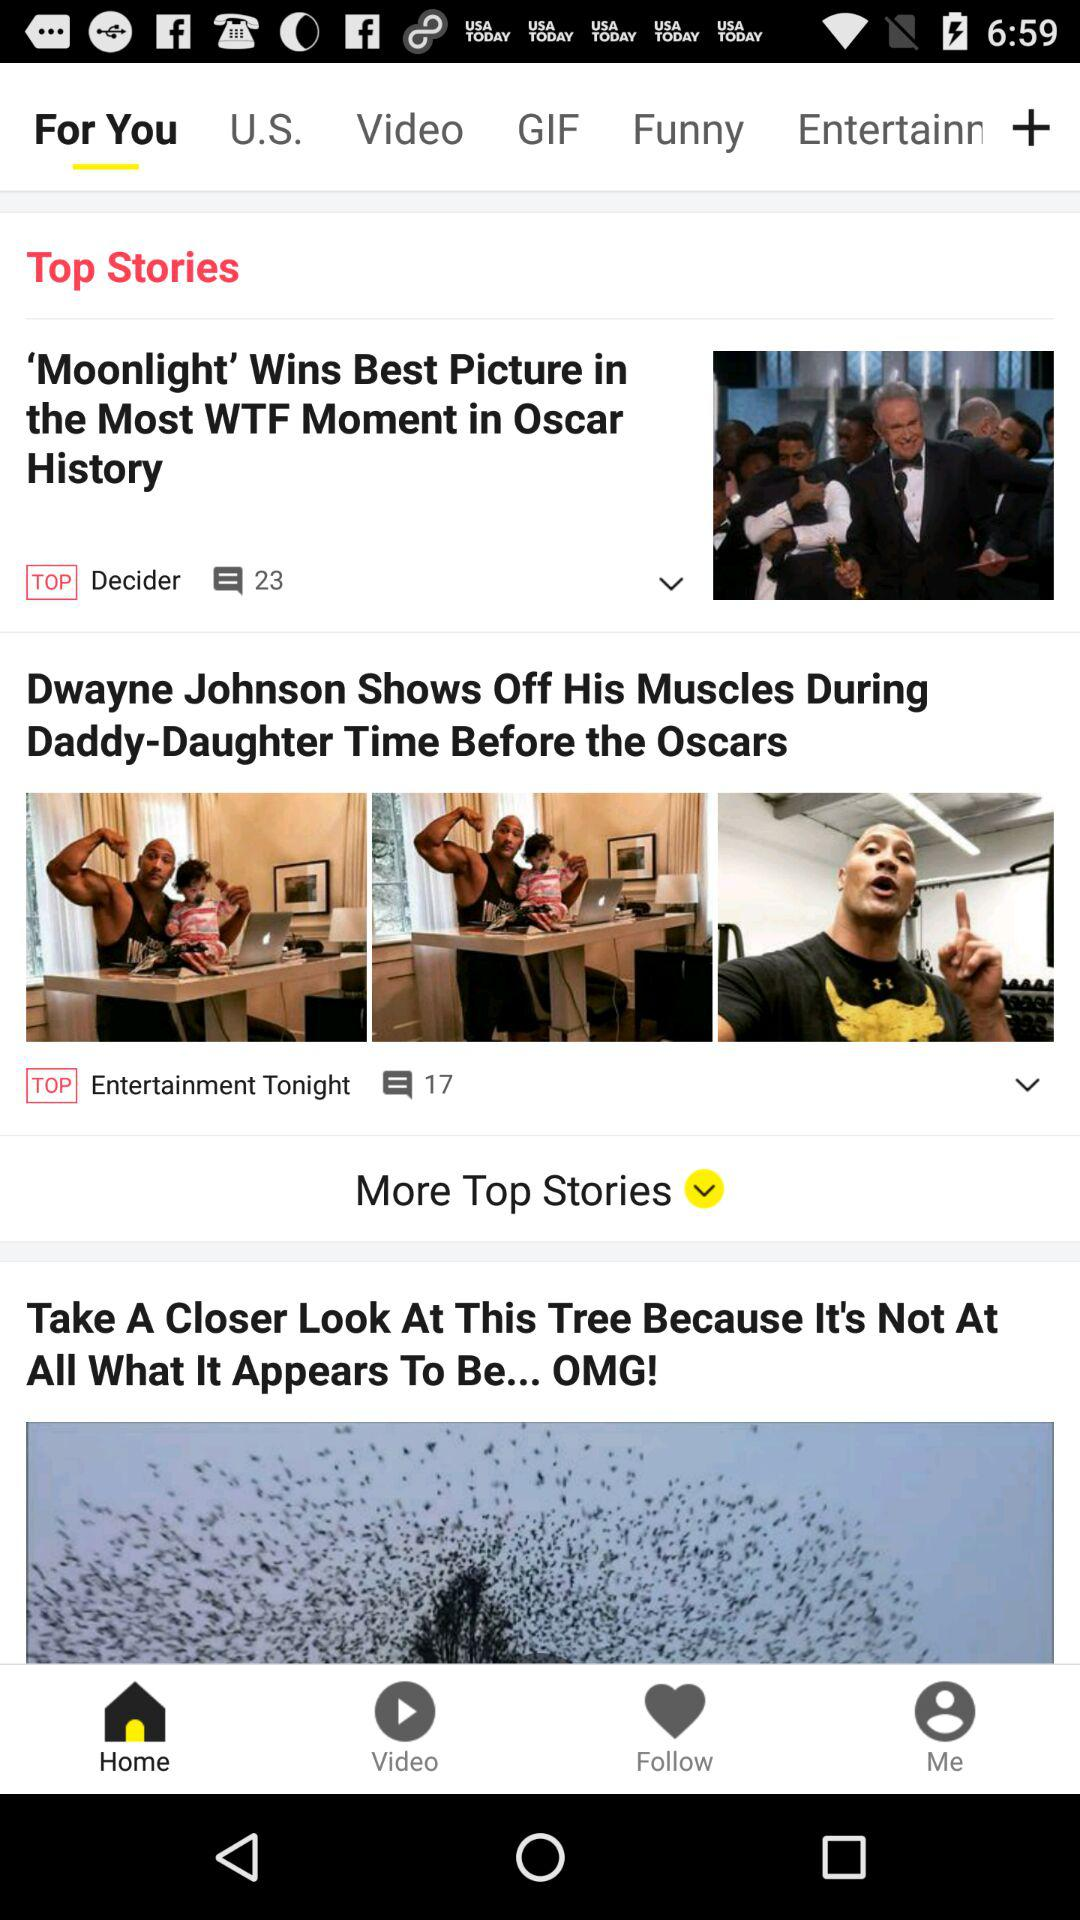How many more top stories are there than regular stories?
Answer the question using a single word or phrase. 1 